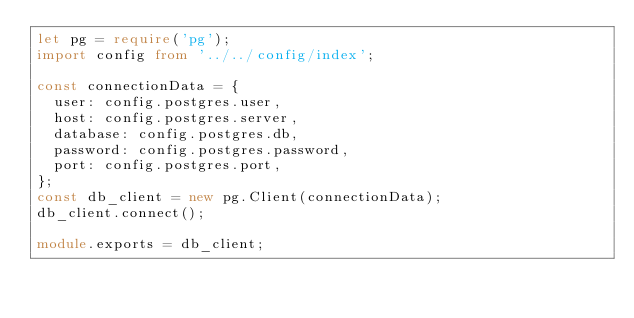<code> <loc_0><loc_0><loc_500><loc_500><_TypeScript_>let pg = require('pg');
import config from '../../config/index';

const connectionData = {
  user: config.postgres.user,
  host: config.postgres.server,
  database: config.postgres.db,
  password: config.postgres.password,
  port: config.postgres.port,
};
const db_client = new pg.Client(connectionData);
db_client.connect();

module.exports = db_client;
</code> 